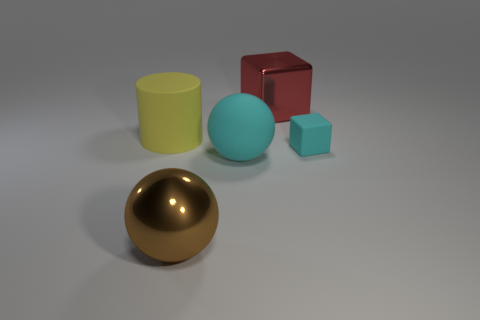How does the lighting in the image affect the mood or appearance of the scene? The lighting in the image creates a soft ambiance with gentle shadows that give the objects a three-dimensional feel. The absence of harsh light or stark contrasts contributes to a calm and neutral mood in the scene. What might be the purpose of this arrangement of objects? The arrangement may serve as a visual demonstration of different geometric shapes and colors, potentially for educational purposes or as a part of graphic design and 3D modeling showcase. 